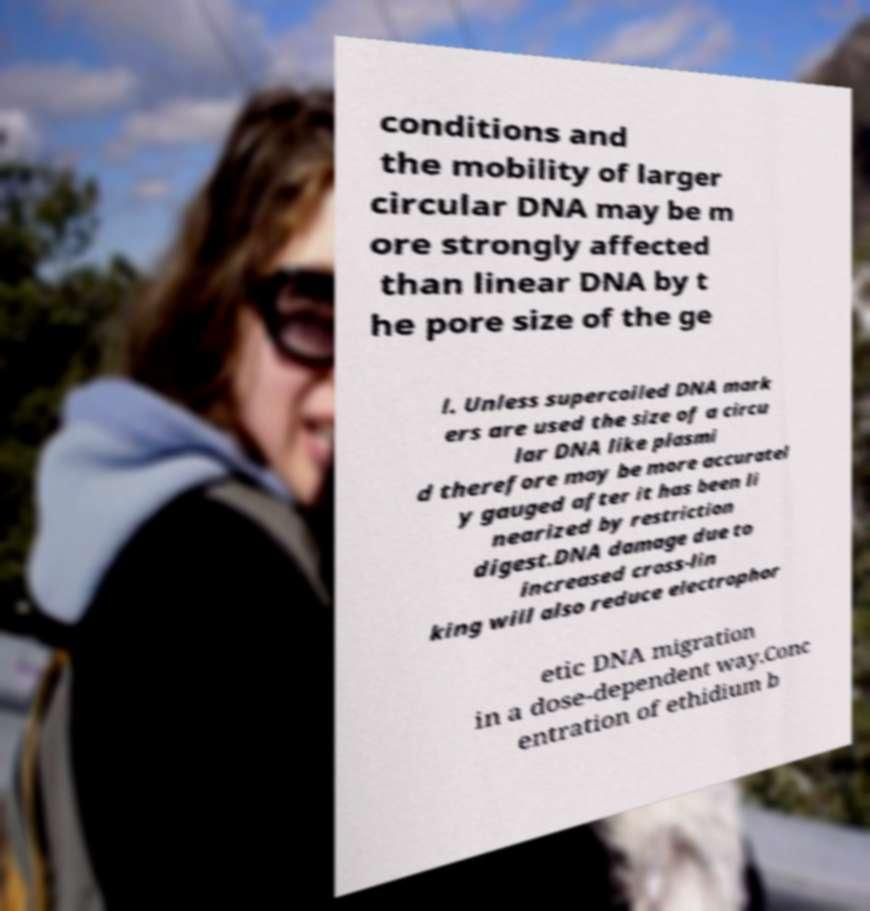Could you extract and type out the text from this image? conditions and the mobility of larger circular DNA may be m ore strongly affected than linear DNA by t he pore size of the ge l. Unless supercoiled DNA mark ers are used the size of a circu lar DNA like plasmi d therefore may be more accuratel y gauged after it has been li nearized by restriction digest.DNA damage due to increased cross-lin king will also reduce electrophor etic DNA migration in a dose-dependent way.Conc entration of ethidium b 